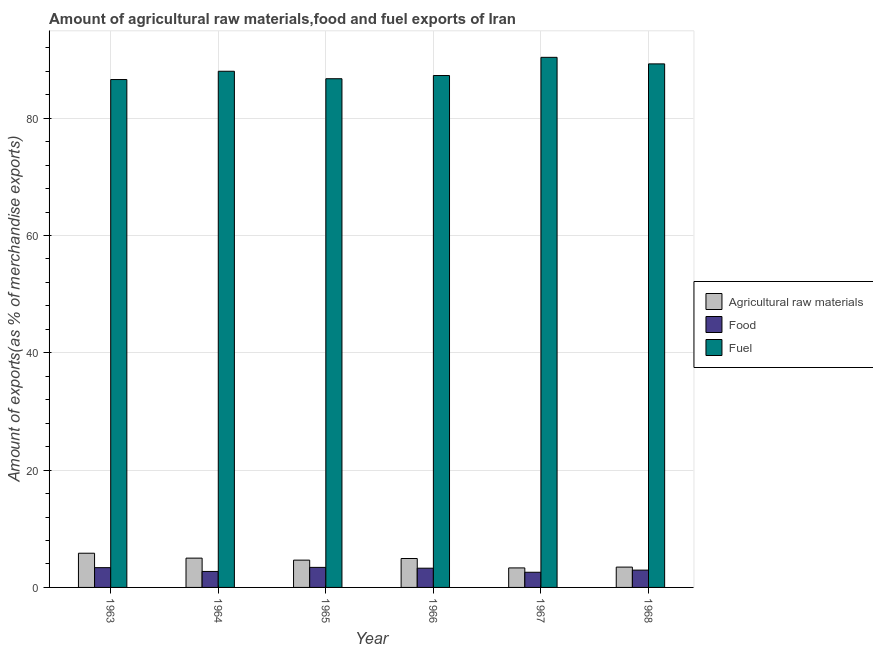How many different coloured bars are there?
Provide a short and direct response. 3. How many groups of bars are there?
Your answer should be compact. 6. What is the label of the 4th group of bars from the left?
Your answer should be very brief. 1966. In how many cases, is the number of bars for a given year not equal to the number of legend labels?
Provide a succinct answer. 0. What is the percentage of food exports in 1966?
Your answer should be compact. 3.28. Across all years, what is the maximum percentage of food exports?
Offer a terse response. 3.42. Across all years, what is the minimum percentage of food exports?
Your answer should be very brief. 2.59. In which year was the percentage of fuel exports maximum?
Keep it short and to the point. 1967. In which year was the percentage of food exports minimum?
Your answer should be very brief. 1967. What is the total percentage of food exports in the graph?
Your answer should be very brief. 18.33. What is the difference between the percentage of fuel exports in 1963 and that in 1967?
Make the answer very short. -3.79. What is the difference between the percentage of fuel exports in 1967 and the percentage of food exports in 1966?
Offer a terse response. 3.1. What is the average percentage of fuel exports per year?
Keep it short and to the point. 88.03. What is the ratio of the percentage of fuel exports in 1965 to that in 1967?
Offer a very short reply. 0.96. Is the percentage of food exports in 1964 less than that in 1968?
Your answer should be very brief. Yes. Is the difference between the percentage of fuel exports in 1963 and 1968 greater than the difference between the percentage of food exports in 1963 and 1968?
Your answer should be compact. No. What is the difference between the highest and the second highest percentage of food exports?
Keep it short and to the point. 0.05. What is the difference between the highest and the lowest percentage of food exports?
Provide a short and direct response. 0.83. What does the 1st bar from the left in 1968 represents?
Provide a succinct answer. Agricultural raw materials. What does the 1st bar from the right in 1967 represents?
Ensure brevity in your answer.  Fuel. Is it the case that in every year, the sum of the percentage of raw materials exports and percentage of food exports is greater than the percentage of fuel exports?
Offer a terse response. No. How many bars are there?
Offer a terse response. 18. Are all the bars in the graph horizontal?
Your answer should be compact. No. How many years are there in the graph?
Your response must be concise. 6. What is the difference between two consecutive major ticks on the Y-axis?
Ensure brevity in your answer.  20. Are the values on the major ticks of Y-axis written in scientific E-notation?
Offer a terse response. No. Does the graph contain any zero values?
Your response must be concise. No. How many legend labels are there?
Make the answer very short. 3. What is the title of the graph?
Your answer should be compact. Amount of agricultural raw materials,food and fuel exports of Iran. What is the label or title of the X-axis?
Offer a terse response. Year. What is the label or title of the Y-axis?
Ensure brevity in your answer.  Amount of exports(as % of merchandise exports). What is the Amount of exports(as % of merchandise exports) in Agricultural raw materials in 1963?
Your response must be concise. 5.83. What is the Amount of exports(as % of merchandise exports) of Food in 1963?
Keep it short and to the point. 3.37. What is the Amount of exports(as % of merchandise exports) in Fuel in 1963?
Keep it short and to the point. 86.59. What is the Amount of exports(as % of merchandise exports) in Agricultural raw materials in 1964?
Provide a succinct answer. 5. What is the Amount of exports(as % of merchandise exports) in Food in 1964?
Make the answer very short. 2.72. What is the Amount of exports(as % of merchandise exports) in Fuel in 1964?
Your answer should be very brief. 88. What is the Amount of exports(as % of merchandise exports) of Agricultural raw materials in 1965?
Your answer should be very brief. 4.65. What is the Amount of exports(as % of merchandise exports) of Food in 1965?
Provide a succinct answer. 3.42. What is the Amount of exports(as % of merchandise exports) in Fuel in 1965?
Keep it short and to the point. 86.72. What is the Amount of exports(as % of merchandise exports) in Agricultural raw materials in 1966?
Give a very brief answer. 4.93. What is the Amount of exports(as % of merchandise exports) of Food in 1966?
Your response must be concise. 3.28. What is the Amount of exports(as % of merchandise exports) in Fuel in 1966?
Offer a terse response. 87.27. What is the Amount of exports(as % of merchandise exports) of Agricultural raw materials in 1967?
Offer a terse response. 3.33. What is the Amount of exports(as % of merchandise exports) in Food in 1967?
Your answer should be compact. 2.59. What is the Amount of exports(as % of merchandise exports) in Fuel in 1967?
Provide a short and direct response. 90.37. What is the Amount of exports(as % of merchandise exports) of Agricultural raw materials in 1968?
Your response must be concise. 3.47. What is the Amount of exports(as % of merchandise exports) in Food in 1968?
Keep it short and to the point. 2.95. What is the Amount of exports(as % of merchandise exports) in Fuel in 1968?
Make the answer very short. 89.25. Across all years, what is the maximum Amount of exports(as % of merchandise exports) of Agricultural raw materials?
Offer a very short reply. 5.83. Across all years, what is the maximum Amount of exports(as % of merchandise exports) of Food?
Your answer should be compact. 3.42. Across all years, what is the maximum Amount of exports(as % of merchandise exports) of Fuel?
Your answer should be very brief. 90.37. Across all years, what is the minimum Amount of exports(as % of merchandise exports) in Agricultural raw materials?
Keep it short and to the point. 3.33. Across all years, what is the minimum Amount of exports(as % of merchandise exports) in Food?
Your answer should be very brief. 2.59. Across all years, what is the minimum Amount of exports(as % of merchandise exports) in Fuel?
Your response must be concise. 86.59. What is the total Amount of exports(as % of merchandise exports) of Agricultural raw materials in the graph?
Keep it short and to the point. 27.2. What is the total Amount of exports(as % of merchandise exports) in Food in the graph?
Your answer should be compact. 18.33. What is the total Amount of exports(as % of merchandise exports) of Fuel in the graph?
Provide a short and direct response. 528.21. What is the difference between the Amount of exports(as % of merchandise exports) in Agricultural raw materials in 1963 and that in 1964?
Your response must be concise. 0.83. What is the difference between the Amount of exports(as % of merchandise exports) in Food in 1963 and that in 1964?
Offer a very short reply. 0.65. What is the difference between the Amount of exports(as % of merchandise exports) of Fuel in 1963 and that in 1964?
Keep it short and to the point. -1.41. What is the difference between the Amount of exports(as % of merchandise exports) in Agricultural raw materials in 1963 and that in 1965?
Make the answer very short. 1.18. What is the difference between the Amount of exports(as % of merchandise exports) in Food in 1963 and that in 1965?
Offer a terse response. -0.05. What is the difference between the Amount of exports(as % of merchandise exports) in Fuel in 1963 and that in 1965?
Provide a succinct answer. -0.14. What is the difference between the Amount of exports(as % of merchandise exports) in Agricultural raw materials in 1963 and that in 1966?
Provide a short and direct response. 0.9. What is the difference between the Amount of exports(as % of merchandise exports) of Food in 1963 and that in 1966?
Provide a short and direct response. 0.09. What is the difference between the Amount of exports(as % of merchandise exports) in Fuel in 1963 and that in 1966?
Your response must be concise. -0.68. What is the difference between the Amount of exports(as % of merchandise exports) in Agricultural raw materials in 1963 and that in 1967?
Provide a succinct answer. 2.5. What is the difference between the Amount of exports(as % of merchandise exports) of Food in 1963 and that in 1967?
Provide a succinct answer. 0.79. What is the difference between the Amount of exports(as % of merchandise exports) in Fuel in 1963 and that in 1967?
Offer a terse response. -3.79. What is the difference between the Amount of exports(as % of merchandise exports) in Agricultural raw materials in 1963 and that in 1968?
Make the answer very short. 2.36. What is the difference between the Amount of exports(as % of merchandise exports) of Food in 1963 and that in 1968?
Offer a very short reply. 0.42. What is the difference between the Amount of exports(as % of merchandise exports) in Fuel in 1963 and that in 1968?
Ensure brevity in your answer.  -2.67. What is the difference between the Amount of exports(as % of merchandise exports) in Agricultural raw materials in 1964 and that in 1965?
Provide a short and direct response. 0.34. What is the difference between the Amount of exports(as % of merchandise exports) in Food in 1964 and that in 1965?
Ensure brevity in your answer.  -0.69. What is the difference between the Amount of exports(as % of merchandise exports) of Fuel in 1964 and that in 1965?
Provide a short and direct response. 1.27. What is the difference between the Amount of exports(as % of merchandise exports) in Agricultural raw materials in 1964 and that in 1966?
Provide a succinct answer. 0.06. What is the difference between the Amount of exports(as % of merchandise exports) of Food in 1964 and that in 1966?
Provide a succinct answer. -0.55. What is the difference between the Amount of exports(as % of merchandise exports) of Fuel in 1964 and that in 1966?
Your answer should be compact. 0.73. What is the difference between the Amount of exports(as % of merchandise exports) in Agricultural raw materials in 1964 and that in 1967?
Your response must be concise. 1.67. What is the difference between the Amount of exports(as % of merchandise exports) of Food in 1964 and that in 1967?
Ensure brevity in your answer.  0.14. What is the difference between the Amount of exports(as % of merchandise exports) in Fuel in 1964 and that in 1967?
Offer a terse response. -2.37. What is the difference between the Amount of exports(as % of merchandise exports) of Agricultural raw materials in 1964 and that in 1968?
Ensure brevity in your answer.  1.53. What is the difference between the Amount of exports(as % of merchandise exports) in Food in 1964 and that in 1968?
Offer a very short reply. -0.23. What is the difference between the Amount of exports(as % of merchandise exports) in Fuel in 1964 and that in 1968?
Your response must be concise. -1.26. What is the difference between the Amount of exports(as % of merchandise exports) in Agricultural raw materials in 1965 and that in 1966?
Your answer should be very brief. -0.28. What is the difference between the Amount of exports(as % of merchandise exports) of Food in 1965 and that in 1966?
Make the answer very short. 0.14. What is the difference between the Amount of exports(as % of merchandise exports) of Fuel in 1965 and that in 1966?
Give a very brief answer. -0.55. What is the difference between the Amount of exports(as % of merchandise exports) in Agricultural raw materials in 1965 and that in 1967?
Provide a short and direct response. 1.33. What is the difference between the Amount of exports(as % of merchandise exports) in Food in 1965 and that in 1967?
Your answer should be compact. 0.83. What is the difference between the Amount of exports(as % of merchandise exports) in Fuel in 1965 and that in 1967?
Your answer should be very brief. -3.65. What is the difference between the Amount of exports(as % of merchandise exports) in Agricultural raw materials in 1965 and that in 1968?
Your answer should be very brief. 1.19. What is the difference between the Amount of exports(as % of merchandise exports) of Food in 1965 and that in 1968?
Ensure brevity in your answer.  0.47. What is the difference between the Amount of exports(as % of merchandise exports) in Fuel in 1965 and that in 1968?
Make the answer very short. -2.53. What is the difference between the Amount of exports(as % of merchandise exports) of Agricultural raw materials in 1966 and that in 1967?
Your response must be concise. 1.6. What is the difference between the Amount of exports(as % of merchandise exports) in Food in 1966 and that in 1967?
Your answer should be compact. 0.69. What is the difference between the Amount of exports(as % of merchandise exports) in Fuel in 1966 and that in 1967?
Keep it short and to the point. -3.1. What is the difference between the Amount of exports(as % of merchandise exports) of Agricultural raw materials in 1966 and that in 1968?
Provide a short and direct response. 1.47. What is the difference between the Amount of exports(as % of merchandise exports) of Food in 1966 and that in 1968?
Provide a short and direct response. 0.33. What is the difference between the Amount of exports(as % of merchandise exports) in Fuel in 1966 and that in 1968?
Your response must be concise. -1.98. What is the difference between the Amount of exports(as % of merchandise exports) of Agricultural raw materials in 1967 and that in 1968?
Your response must be concise. -0.14. What is the difference between the Amount of exports(as % of merchandise exports) of Food in 1967 and that in 1968?
Offer a very short reply. -0.37. What is the difference between the Amount of exports(as % of merchandise exports) in Fuel in 1967 and that in 1968?
Offer a very short reply. 1.12. What is the difference between the Amount of exports(as % of merchandise exports) of Agricultural raw materials in 1963 and the Amount of exports(as % of merchandise exports) of Food in 1964?
Ensure brevity in your answer.  3.11. What is the difference between the Amount of exports(as % of merchandise exports) in Agricultural raw materials in 1963 and the Amount of exports(as % of merchandise exports) in Fuel in 1964?
Make the answer very short. -82.17. What is the difference between the Amount of exports(as % of merchandise exports) in Food in 1963 and the Amount of exports(as % of merchandise exports) in Fuel in 1964?
Keep it short and to the point. -84.63. What is the difference between the Amount of exports(as % of merchandise exports) in Agricultural raw materials in 1963 and the Amount of exports(as % of merchandise exports) in Food in 1965?
Keep it short and to the point. 2.41. What is the difference between the Amount of exports(as % of merchandise exports) of Agricultural raw materials in 1963 and the Amount of exports(as % of merchandise exports) of Fuel in 1965?
Offer a terse response. -80.89. What is the difference between the Amount of exports(as % of merchandise exports) of Food in 1963 and the Amount of exports(as % of merchandise exports) of Fuel in 1965?
Give a very brief answer. -83.35. What is the difference between the Amount of exports(as % of merchandise exports) in Agricultural raw materials in 1963 and the Amount of exports(as % of merchandise exports) in Food in 1966?
Give a very brief answer. 2.55. What is the difference between the Amount of exports(as % of merchandise exports) of Agricultural raw materials in 1963 and the Amount of exports(as % of merchandise exports) of Fuel in 1966?
Make the answer very short. -81.44. What is the difference between the Amount of exports(as % of merchandise exports) in Food in 1963 and the Amount of exports(as % of merchandise exports) in Fuel in 1966?
Keep it short and to the point. -83.9. What is the difference between the Amount of exports(as % of merchandise exports) of Agricultural raw materials in 1963 and the Amount of exports(as % of merchandise exports) of Food in 1967?
Make the answer very short. 3.24. What is the difference between the Amount of exports(as % of merchandise exports) of Agricultural raw materials in 1963 and the Amount of exports(as % of merchandise exports) of Fuel in 1967?
Your answer should be very brief. -84.54. What is the difference between the Amount of exports(as % of merchandise exports) in Food in 1963 and the Amount of exports(as % of merchandise exports) in Fuel in 1967?
Offer a terse response. -87. What is the difference between the Amount of exports(as % of merchandise exports) in Agricultural raw materials in 1963 and the Amount of exports(as % of merchandise exports) in Food in 1968?
Provide a succinct answer. 2.88. What is the difference between the Amount of exports(as % of merchandise exports) in Agricultural raw materials in 1963 and the Amount of exports(as % of merchandise exports) in Fuel in 1968?
Your answer should be very brief. -83.43. What is the difference between the Amount of exports(as % of merchandise exports) in Food in 1963 and the Amount of exports(as % of merchandise exports) in Fuel in 1968?
Make the answer very short. -85.88. What is the difference between the Amount of exports(as % of merchandise exports) of Agricultural raw materials in 1964 and the Amount of exports(as % of merchandise exports) of Food in 1965?
Ensure brevity in your answer.  1.58. What is the difference between the Amount of exports(as % of merchandise exports) of Agricultural raw materials in 1964 and the Amount of exports(as % of merchandise exports) of Fuel in 1965?
Keep it short and to the point. -81.73. What is the difference between the Amount of exports(as % of merchandise exports) in Food in 1964 and the Amount of exports(as % of merchandise exports) in Fuel in 1965?
Offer a terse response. -84. What is the difference between the Amount of exports(as % of merchandise exports) of Agricultural raw materials in 1964 and the Amount of exports(as % of merchandise exports) of Food in 1966?
Your answer should be compact. 1.72. What is the difference between the Amount of exports(as % of merchandise exports) in Agricultural raw materials in 1964 and the Amount of exports(as % of merchandise exports) in Fuel in 1966?
Offer a very short reply. -82.28. What is the difference between the Amount of exports(as % of merchandise exports) in Food in 1964 and the Amount of exports(as % of merchandise exports) in Fuel in 1966?
Provide a succinct answer. -84.55. What is the difference between the Amount of exports(as % of merchandise exports) of Agricultural raw materials in 1964 and the Amount of exports(as % of merchandise exports) of Food in 1967?
Provide a short and direct response. 2.41. What is the difference between the Amount of exports(as % of merchandise exports) in Agricultural raw materials in 1964 and the Amount of exports(as % of merchandise exports) in Fuel in 1967?
Your response must be concise. -85.38. What is the difference between the Amount of exports(as % of merchandise exports) in Food in 1964 and the Amount of exports(as % of merchandise exports) in Fuel in 1967?
Your response must be concise. -87.65. What is the difference between the Amount of exports(as % of merchandise exports) of Agricultural raw materials in 1964 and the Amount of exports(as % of merchandise exports) of Food in 1968?
Provide a short and direct response. 2.04. What is the difference between the Amount of exports(as % of merchandise exports) of Agricultural raw materials in 1964 and the Amount of exports(as % of merchandise exports) of Fuel in 1968?
Ensure brevity in your answer.  -84.26. What is the difference between the Amount of exports(as % of merchandise exports) in Food in 1964 and the Amount of exports(as % of merchandise exports) in Fuel in 1968?
Provide a short and direct response. -86.53. What is the difference between the Amount of exports(as % of merchandise exports) in Agricultural raw materials in 1965 and the Amount of exports(as % of merchandise exports) in Food in 1966?
Your answer should be very brief. 1.37. What is the difference between the Amount of exports(as % of merchandise exports) of Agricultural raw materials in 1965 and the Amount of exports(as % of merchandise exports) of Fuel in 1966?
Offer a very short reply. -82.62. What is the difference between the Amount of exports(as % of merchandise exports) of Food in 1965 and the Amount of exports(as % of merchandise exports) of Fuel in 1966?
Your answer should be compact. -83.85. What is the difference between the Amount of exports(as % of merchandise exports) of Agricultural raw materials in 1965 and the Amount of exports(as % of merchandise exports) of Food in 1967?
Your answer should be very brief. 2.07. What is the difference between the Amount of exports(as % of merchandise exports) in Agricultural raw materials in 1965 and the Amount of exports(as % of merchandise exports) in Fuel in 1967?
Provide a succinct answer. -85.72. What is the difference between the Amount of exports(as % of merchandise exports) of Food in 1965 and the Amount of exports(as % of merchandise exports) of Fuel in 1967?
Offer a very short reply. -86.95. What is the difference between the Amount of exports(as % of merchandise exports) of Agricultural raw materials in 1965 and the Amount of exports(as % of merchandise exports) of Food in 1968?
Give a very brief answer. 1.7. What is the difference between the Amount of exports(as % of merchandise exports) of Agricultural raw materials in 1965 and the Amount of exports(as % of merchandise exports) of Fuel in 1968?
Provide a succinct answer. -84.6. What is the difference between the Amount of exports(as % of merchandise exports) in Food in 1965 and the Amount of exports(as % of merchandise exports) in Fuel in 1968?
Your answer should be compact. -85.84. What is the difference between the Amount of exports(as % of merchandise exports) in Agricultural raw materials in 1966 and the Amount of exports(as % of merchandise exports) in Food in 1967?
Offer a very short reply. 2.35. What is the difference between the Amount of exports(as % of merchandise exports) of Agricultural raw materials in 1966 and the Amount of exports(as % of merchandise exports) of Fuel in 1967?
Your response must be concise. -85.44. What is the difference between the Amount of exports(as % of merchandise exports) in Food in 1966 and the Amount of exports(as % of merchandise exports) in Fuel in 1967?
Your answer should be very brief. -87.09. What is the difference between the Amount of exports(as % of merchandise exports) in Agricultural raw materials in 1966 and the Amount of exports(as % of merchandise exports) in Food in 1968?
Your response must be concise. 1.98. What is the difference between the Amount of exports(as % of merchandise exports) of Agricultural raw materials in 1966 and the Amount of exports(as % of merchandise exports) of Fuel in 1968?
Provide a short and direct response. -84.32. What is the difference between the Amount of exports(as % of merchandise exports) in Food in 1966 and the Amount of exports(as % of merchandise exports) in Fuel in 1968?
Provide a succinct answer. -85.98. What is the difference between the Amount of exports(as % of merchandise exports) of Agricultural raw materials in 1967 and the Amount of exports(as % of merchandise exports) of Food in 1968?
Make the answer very short. 0.38. What is the difference between the Amount of exports(as % of merchandise exports) of Agricultural raw materials in 1967 and the Amount of exports(as % of merchandise exports) of Fuel in 1968?
Provide a short and direct response. -85.93. What is the difference between the Amount of exports(as % of merchandise exports) in Food in 1967 and the Amount of exports(as % of merchandise exports) in Fuel in 1968?
Ensure brevity in your answer.  -86.67. What is the average Amount of exports(as % of merchandise exports) in Agricultural raw materials per year?
Your answer should be very brief. 4.53. What is the average Amount of exports(as % of merchandise exports) of Food per year?
Offer a very short reply. 3.05. What is the average Amount of exports(as % of merchandise exports) in Fuel per year?
Keep it short and to the point. 88.03. In the year 1963, what is the difference between the Amount of exports(as % of merchandise exports) of Agricultural raw materials and Amount of exports(as % of merchandise exports) of Food?
Ensure brevity in your answer.  2.46. In the year 1963, what is the difference between the Amount of exports(as % of merchandise exports) in Agricultural raw materials and Amount of exports(as % of merchandise exports) in Fuel?
Make the answer very short. -80.76. In the year 1963, what is the difference between the Amount of exports(as % of merchandise exports) in Food and Amount of exports(as % of merchandise exports) in Fuel?
Offer a very short reply. -83.22. In the year 1964, what is the difference between the Amount of exports(as % of merchandise exports) in Agricultural raw materials and Amount of exports(as % of merchandise exports) in Food?
Your answer should be very brief. 2.27. In the year 1964, what is the difference between the Amount of exports(as % of merchandise exports) of Agricultural raw materials and Amount of exports(as % of merchandise exports) of Fuel?
Your answer should be compact. -83. In the year 1964, what is the difference between the Amount of exports(as % of merchandise exports) in Food and Amount of exports(as % of merchandise exports) in Fuel?
Your answer should be very brief. -85.27. In the year 1965, what is the difference between the Amount of exports(as % of merchandise exports) of Agricultural raw materials and Amount of exports(as % of merchandise exports) of Food?
Ensure brevity in your answer.  1.23. In the year 1965, what is the difference between the Amount of exports(as % of merchandise exports) in Agricultural raw materials and Amount of exports(as % of merchandise exports) in Fuel?
Keep it short and to the point. -82.07. In the year 1965, what is the difference between the Amount of exports(as % of merchandise exports) of Food and Amount of exports(as % of merchandise exports) of Fuel?
Keep it short and to the point. -83.31. In the year 1966, what is the difference between the Amount of exports(as % of merchandise exports) in Agricultural raw materials and Amount of exports(as % of merchandise exports) in Food?
Provide a short and direct response. 1.65. In the year 1966, what is the difference between the Amount of exports(as % of merchandise exports) of Agricultural raw materials and Amount of exports(as % of merchandise exports) of Fuel?
Ensure brevity in your answer.  -82.34. In the year 1966, what is the difference between the Amount of exports(as % of merchandise exports) in Food and Amount of exports(as % of merchandise exports) in Fuel?
Give a very brief answer. -83.99. In the year 1967, what is the difference between the Amount of exports(as % of merchandise exports) in Agricultural raw materials and Amount of exports(as % of merchandise exports) in Food?
Keep it short and to the point. 0.74. In the year 1967, what is the difference between the Amount of exports(as % of merchandise exports) in Agricultural raw materials and Amount of exports(as % of merchandise exports) in Fuel?
Your response must be concise. -87.05. In the year 1967, what is the difference between the Amount of exports(as % of merchandise exports) in Food and Amount of exports(as % of merchandise exports) in Fuel?
Offer a terse response. -87.79. In the year 1968, what is the difference between the Amount of exports(as % of merchandise exports) of Agricultural raw materials and Amount of exports(as % of merchandise exports) of Food?
Your response must be concise. 0.52. In the year 1968, what is the difference between the Amount of exports(as % of merchandise exports) of Agricultural raw materials and Amount of exports(as % of merchandise exports) of Fuel?
Provide a short and direct response. -85.79. In the year 1968, what is the difference between the Amount of exports(as % of merchandise exports) of Food and Amount of exports(as % of merchandise exports) of Fuel?
Provide a succinct answer. -86.3. What is the ratio of the Amount of exports(as % of merchandise exports) in Agricultural raw materials in 1963 to that in 1964?
Give a very brief answer. 1.17. What is the ratio of the Amount of exports(as % of merchandise exports) in Food in 1963 to that in 1964?
Ensure brevity in your answer.  1.24. What is the ratio of the Amount of exports(as % of merchandise exports) of Fuel in 1963 to that in 1964?
Your answer should be very brief. 0.98. What is the ratio of the Amount of exports(as % of merchandise exports) in Agricultural raw materials in 1963 to that in 1965?
Your answer should be compact. 1.25. What is the ratio of the Amount of exports(as % of merchandise exports) in Food in 1963 to that in 1965?
Make the answer very short. 0.99. What is the ratio of the Amount of exports(as % of merchandise exports) of Agricultural raw materials in 1963 to that in 1966?
Your answer should be compact. 1.18. What is the ratio of the Amount of exports(as % of merchandise exports) of Food in 1963 to that in 1966?
Give a very brief answer. 1.03. What is the ratio of the Amount of exports(as % of merchandise exports) of Agricultural raw materials in 1963 to that in 1967?
Provide a succinct answer. 1.75. What is the ratio of the Amount of exports(as % of merchandise exports) in Food in 1963 to that in 1967?
Offer a very short reply. 1.3. What is the ratio of the Amount of exports(as % of merchandise exports) of Fuel in 1963 to that in 1967?
Provide a short and direct response. 0.96. What is the ratio of the Amount of exports(as % of merchandise exports) of Agricultural raw materials in 1963 to that in 1968?
Provide a succinct answer. 1.68. What is the ratio of the Amount of exports(as % of merchandise exports) in Food in 1963 to that in 1968?
Provide a short and direct response. 1.14. What is the ratio of the Amount of exports(as % of merchandise exports) of Fuel in 1963 to that in 1968?
Offer a very short reply. 0.97. What is the ratio of the Amount of exports(as % of merchandise exports) of Agricultural raw materials in 1964 to that in 1965?
Make the answer very short. 1.07. What is the ratio of the Amount of exports(as % of merchandise exports) of Food in 1964 to that in 1965?
Give a very brief answer. 0.8. What is the ratio of the Amount of exports(as % of merchandise exports) in Fuel in 1964 to that in 1965?
Keep it short and to the point. 1.01. What is the ratio of the Amount of exports(as % of merchandise exports) of Agricultural raw materials in 1964 to that in 1966?
Your response must be concise. 1.01. What is the ratio of the Amount of exports(as % of merchandise exports) of Food in 1964 to that in 1966?
Offer a very short reply. 0.83. What is the ratio of the Amount of exports(as % of merchandise exports) of Fuel in 1964 to that in 1966?
Offer a very short reply. 1.01. What is the ratio of the Amount of exports(as % of merchandise exports) of Agricultural raw materials in 1964 to that in 1967?
Offer a very short reply. 1.5. What is the ratio of the Amount of exports(as % of merchandise exports) in Food in 1964 to that in 1967?
Offer a terse response. 1.05. What is the ratio of the Amount of exports(as % of merchandise exports) in Fuel in 1964 to that in 1967?
Provide a short and direct response. 0.97. What is the ratio of the Amount of exports(as % of merchandise exports) of Agricultural raw materials in 1964 to that in 1968?
Your answer should be very brief. 1.44. What is the ratio of the Amount of exports(as % of merchandise exports) in Fuel in 1964 to that in 1968?
Provide a succinct answer. 0.99. What is the ratio of the Amount of exports(as % of merchandise exports) of Agricultural raw materials in 1965 to that in 1966?
Ensure brevity in your answer.  0.94. What is the ratio of the Amount of exports(as % of merchandise exports) of Food in 1965 to that in 1966?
Make the answer very short. 1.04. What is the ratio of the Amount of exports(as % of merchandise exports) of Fuel in 1965 to that in 1966?
Your answer should be compact. 0.99. What is the ratio of the Amount of exports(as % of merchandise exports) in Agricultural raw materials in 1965 to that in 1967?
Give a very brief answer. 1.4. What is the ratio of the Amount of exports(as % of merchandise exports) in Food in 1965 to that in 1967?
Your answer should be compact. 1.32. What is the ratio of the Amount of exports(as % of merchandise exports) in Fuel in 1965 to that in 1967?
Give a very brief answer. 0.96. What is the ratio of the Amount of exports(as % of merchandise exports) in Agricultural raw materials in 1965 to that in 1968?
Your answer should be very brief. 1.34. What is the ratio of the Amount of exports(as % of merchandise exports) of Food in 1965 to that in 1968?
Provide a succinct answer. 1.16. What is the ratio of the Amount of exports(as % of merchandise exports) of Fuel in 1965 to that in 1968?
Your answer should be compact. 0.97. What is the ratio of the Amount of exports(as % of merchandise exports) of Agricultural raw materials in 1966 to that in 1967?
Ensure brevity in your answer.  1.48. What is the ratio of the Amount of exports(as % of merchandise exports) in Food in 1966 to that in 1967?
Keep it short and to the point. 1.27. What is the ratio of the Amount of exports(as % of merchandise exports) of Fuel in 1966 to that in 1967?
Offer a terse response. 0.97. What is the ratio of the Amount of exports(as % of merchandise exports) of Agricultural raw materials in 1966 to that in 1968?
Your answer should be compact. 1.42. What is the ratio of the Amount of exports(as % of merchandise exports) of Food in 1966 to that in 1968?
Offer a very short reply. 1.11. What is the ratio of the Amount of exports(as % of merchandise exports) of Fuel in 1966 to that in 1968?
Keep it short and to the point. 0.98. What is the ratio of the Amount of exports(as % of merchandise exports) of Agricultural raw materials in 1967 to that in 1968?
Ensure brevity in your answer.  0.96. What is the ratio of the Amount of exports(as % of merchandise exports) in Food in 1967 to that in 1968?
Provide a succinct answer. 0.88. What is the ratio of the Amount of exports(as % of merchandise exports) of Fuel in 1967 to that in 1968?
Your response must be concise. 1.01. What is the difference between the highest and the second highest Amount of exports(as % of merchandise exports) in Agricultural raw materials?
Keep it short and to the point. 0.83. What is the difference between the highest and the second highest Amount of exports(as % of merchandise exports) of Food?
Offer a very short reply. 0.05. What is the difference between the highest and the second highest Amount of exports(as % of merchandise exports) in Fuel?
Provide a short and direct response. 1.12. What is the difference between the highest and the lowest Amount of exports(as % of merchandise exports) in Agricultural raw materials?
Keep it short and to the point. 2.5. What is the difference between the highest and the lowest Amount of exports(as % of merchandise exports) in Food?
Provide a short and direct response. 0.83. What is the difference between the highest and the lowest Amount of exports(as % of merchandise exports) of Fuel?
Ensure brevity in your answer.  3.79. 